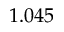<formula> <loc_0><loc_0><loc_500><loc_500>1 . 0 4 5</formula> 